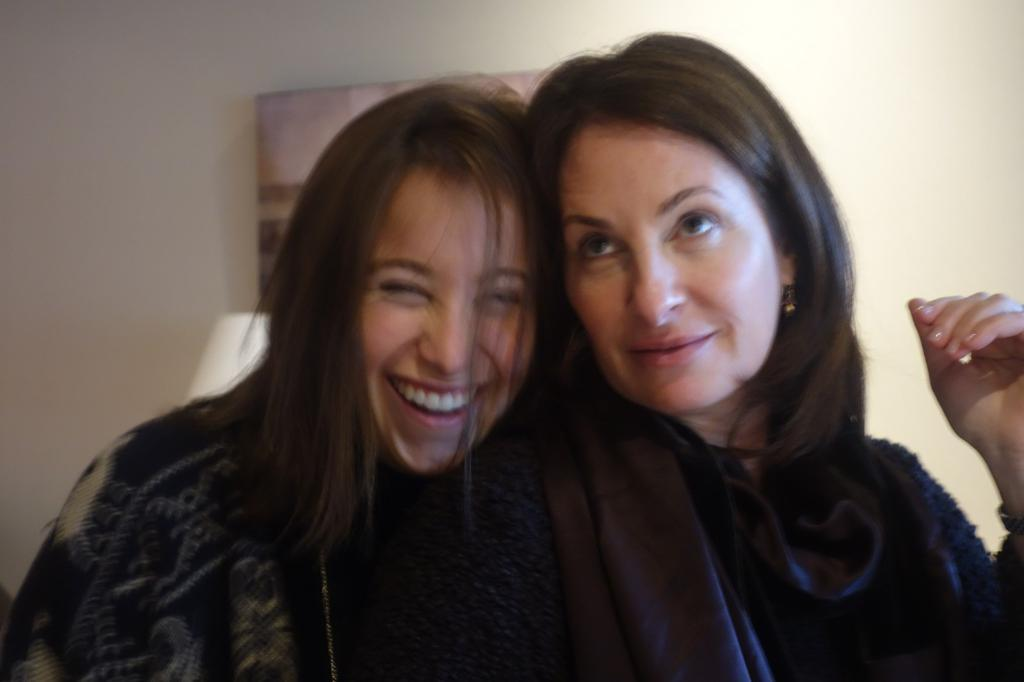How many people are in the image? There are two persons in the image. What are the persons wearing? The persons are wearing clothes. What can be seen in the background of the image? There is a wall in the background of the image. What type of key is being used to unlock the stone on the dock in the image? There is no key, stone, or dock present in the image. 